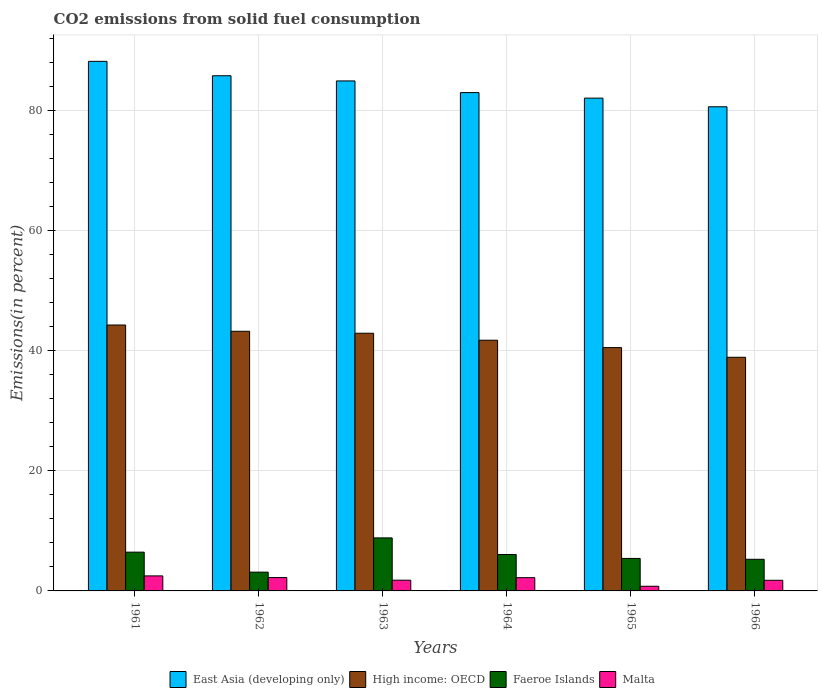How many different coloured bars are there?
Provide a short and direct response. 4. Are the number of bars on each tick of the X-axis equal?
Give a very brief answer. Yes. What is the label of the 5th group of bars from the left?
Your answer should be very brief. 1965. In how many cases, is the number of bars for a given year not equal to the number of legend labels?
Make the answer very short. 0. What is the total CO2 emitted in East Asia (developing only) in 1961?
Offer a terse response. 88.12. Across all years, what is the maximum total CO2 emitted in Malta?
Your answer should be compact. 2.5. Across all years, what is the minimum total CO2 emitted in High income: OECD?
Your answer should be very brief. 38.88. In which year was the total CO2 emitted in Malta minimum?
Your response must be concise. 1965. What is the total total CO2 emitted in East Asia (developing only) in the graph?
Your answer should be very brief. 504.17. What is the difference between the total CO2 emitted in Faeroe Islands in 1961 and that in 1966?
Make the answer very short. 1.19. What is the difference between the total CO2 emitted in Malta in 1966 and the total CO2 emitted in East Asia (developing only) in 1963?
Make the answer very short. -83.09. What is the average total CO2 emitted in High income: OECD per year?
Your answer should be very brief. 41.9. In the year 1964, what is the difference between the total CO2 emitted in Malta and total CO2 emitted in Faeroe Islands?
Make the answer very short. -3.85. What is the ratio of the total CO2 emitted in Malta in 1964 to that in 1966?
Give a very brief answer. 1.25. Is the difference between the total CO2 emitted in Malta in 1961 and 1966 greater than the difference between the total CO2 emitted in Faeroe Islands in 1961 and 1966?
Offer a terse response. No. What is the difference between the highest and the second highest total CO2 emitted in Faeroe Islands?
Your response must be concise. 2.37. What is the difference between the highest and the lowest total CO2 emitted in East Asia (developing only)?
Provide a succinct answer. 7.56. What does the 2nd bar from the left in 1963 represents?
Your answer should be very brief. High income: OECD. What does the 2nd bar from the right in 1966 represents?
Offer a terse response. Faeroe Islands. How many bars are there?
Keep it short and to the point. 24. Does the graph contain any zero values?
Provide a short and direct response. No. Does the graph contain grids?
Offer a terse response. Yes. Where does the legend appear in the graph?
Offer a very short reply. Bottom center. What is the title of the graph?
Provide a succinct answer. CO2 emissions from solid fuel consumption. Does "Burundi" appear as one of the legend labels in the graph?
Make the answer very short. No. What is the label or title of the X-axis?
Offer a terse response. Years. What is the label or title of the Y-axis?
Provide a succinct answer. Emissions(in percent). What is the Emissions(in percent) of East Asia (developing only) in 1961?
Keep it short and to the point. 88.12. What is the Emissions(in percent) in High income: OECD in 1961?
Give a very brief answer. 44.25. What is the Emissions(in percent) in Faeroe Islands in 1961?
Keep it short and to the point. 6.45. What is the Emissions(in percent) of East Asia (developing only) in 1962?
Provide a succinct answer. 85.72. What is the Emissions(in percent) in High income: OECD in 1962?
Your answer should be very brief. 43.2. What is the Emissions(in percent) of Faeroe Islands in 1962?
Ensure brevity in your answer.  3.12. What is the Emissions(in percent) in Malta in 1962?
Offer a very short reply. 2.22. What is the Emissions(in percent) of East Asia (developing only) in 1963?
Your answer should be compact. 84.86. What is the Emissions(in percent) of High income: OECD in 1963?
Your response must be concise. 42.88. What is the Emissions(in percent) of Faeroe Islands in 1963?
Keep it short and to the point. 8.82. What is the Emissions(in percent) of Malta in 1963?
Provide a succinct answer. 1.79. What is the Emissions(in percent) in East Asia (developing only) in 1964?
Provide a succinct answer. 82.92. What is the Emissions(in percent) in High income: OECD in 1964?
Your answer should be very brief. 41.72. What is the Emissions(in percent) in Faeroe Islands in 1964?
Provide a succinct answer. 6.06. What is the Emissions(in percent) of Malta in 1964?
Offer a terse response. 2.21. What is the Emissions(in percent) in East Asia (developing only) in 1965?
Offer a very short reply. 82. What is the Emissions(in percent) in High income: OECD in 1965?
Make the answer very short. 40.49. What is the Emissions(in percent) in Faeroe Islands in 1965?
Your answer should be compact. 5.41. What is the Emissions(in percent) of Malta in 1965?
Give a very brief answer. 0.78. What is the Emissions(in percent) of East Asia (developing only) in 1966?
Your answer should be very brief. 80.56. What is the Emissions(in percent) in High income: OECD in 1966?
Ensure brevity in your answer.  38.88. What is the Emissions(in percent) in Faeroe Islands in 1966?
Your answer should be very brief. 5.26. What is the Emissions(in percent) of Malta in 1966?
Your response must be concise. 1.77. Across all years, what is the maximum Emissions(in percent) of East Asia (developing only)?
Offer a terse response. 88.12. Across all years, what is the maximum Emissions(in percent) of High income: OECD?
Make the answer very short. 44.25. Across all years, what is the maximum Emissions(in percent) of Faeroe Islands?
Provide a succinct answer. 8.82. Across all years, what is the minimum Emissions(in percent) of East Asia (developing only)?
Your response must be concise. 80.56. Across all years, what is the minimum Emissions(in percent) of High income: OECD?
Provide a short and direct response. 38.88. Across all years, what is the minimum Emissions(in percent) in Faeroe Islands?
Give a very brief answer. 3.12. Across all years, what is the minimum Emissions(in percent) in Malta?
Keep it short and to the point. 0.78. What is the total Emissions(in percent) of East Asia (developing only) in the graph?
Offer a very short reply. 504.17. What is the total Emissions(in percent) in High income: OECD in the graph?
Give a very brief answer. 251.41. What is the total Emissions(in percent) of Faeroe Islands in the graph?
Provide a short and direct response. 35.13. What is the total Emissions(in percent) of Malta in the graph?
Keep it short and to the point. 11.26. What is the difference between the Emissions(in percent) in East Asia (developing only) in 1961 and that in 1962?
Offer a terse response. 2.4. What is the difference between the Emissions(in percent) of High income: OECD in 1961 and that in 1962?
Ensure brevity in your answer.  1.04. What is the difference between the Emissions(in percent) in Faeroe Islands in 1961 and that in 1962?
Keep it short and to the point. 3.33. What is the difference between the Emissions(in percent) of Malta in 1961 and that in 1962?
Your answer should be compact. 0.28. What is the difference between the Emissions(in percent) in East Asia (developing only) in 1961 and that in 1963?
Provide a succinct answer. 3.26. What is the difference between the Emissions(in percent) in High income: OECD in 1961 and that in 1963?
Offer a very short reply. 1.37. What is the difference between the Emissions(in percent) of Faeroe Islands in 1961 and that in 1963?
Ensure brevity in your answer.  -2.37. What is the difference between the Emissions(in percent) in East Asia (developing only) in 1961 and that in 1964?
Make the answer very short. 5.2. What is the difference between the Emissions(in percent) in High income: OECD in 1961 and that in 1964?
Offer a terse response. 2.53. What is the difference between the Emissions(in percent) of Faeroe Islands in 1961 and that in 1964?
Provide a succinct answer. 0.39. What is the difference between the Emissions(in percent) of Malta in 1961 and that in 1964?
Your response must be concise. 0.29. What is the difference between the Emissions(in percent) of East Asia (developing only) in 1961 and that in 1965?
Keep it short and to the point. 6.12. What is the difference between the Emissions(in percent) in High income: OECD in 1961 and that in 1965?
Keep it short and to the point. 3.76. What is the difference between the Emissions(in percent) in Faeroe Islands in 1961 and that in 1965?
Your answer should be very brief. 1.05. What is the difference between the Emissions(in percent) in Malta in 1961 and that in 1965?
Provide a succinct answer. 1.72. What is the difference between the Emissions(in percent) in East Asia (developing only) in 1961 and that in 1966?
Your answer should be compact. 7.56. What is the difference between the Emissions(in percent) of High income: OECD in 1961 and that in 1966?
Give a very brief answer. 5.37. What is the difference between the Emissions(in percent) of Faeroe Islands in 1961 and that in 1966?
Your answer should be very brief. 1.19. What is the difference between the Emissions(in percent) in Malta in 1961 and that in 1966?
Provide a succinct answer. 0.73. What is the difference between the Emissions(in percent) in East Asia (developing only) in 1962 and that in 1963?
Your answer should be very brief. 0.86. What is the difference between the Emissions(in percent) in High income: OECD in 1962 and that in 1963?
Provide a short and direct response. 0.33. What is the difference between the Emissions(in percent) in Faeroe Islands in 1962 and that in 1963?
Offer a very short reply. -5.7. What is the difference between the Emissions(in percent) of Malta in 1962 and that in 1963?
Ensure brevity in your answer.  0.44. What is the difference between the Emissions(in percent) in East Asia (developing only) in 1962 and that in 1964?
Your answer should be very brief. 2.8. What is the difference between the Emissions(in percent) in High income: OECD in 1962 and that in 1964?
Offer a very short reply. 1.49. What is the difference between the Emissions(in percent) in Faeroe Islands in 1962 and that in 1964?
Your response must be concise. -2.94. What is the difference between the Emissions(in percent) in Malta in 1962 and that in 1964?
Your answer should be compact. 0.02. What is the difference between the Emissions(in percent) of East Asia (developing only) in 1962 and that in 1965?
Keep it short and to the point. 3.72. What is the difference between the Emissions(in percent) of High income: OECD in 1962 and that in 1965?
Provide a short and direct response. 2.72. What is the difference between the Emissions(in percent) of Faeroe Islands in 1962 and that in 1965?
Offer a very short reply. -2.28. What is the difference between the Emissions(in percent) in Malta in 1962 and that in 1965?
Keep it short and to the point. 1.45. What is the difference between the Emissions(in percent) in East Asia (developing only) in 1962 and that in 1966?
Give a very brief answer. 5.16. What is the difference between the Emissions(in percent) of High income: OECD in 1962 and that in 1966?
Keep it short and to the point. 4.33. What is the difference between the Emissions(in percent) in Faeroe Islands in 1962 and that in 1966?
Your answer should be very brief. -2.14. What is the difference between the Emissions(in percent) of Malta in 1962 and that in 1966?
Offer a very short reply. 0.45. What is the difference between the Emissions(in percent) of East Asia (developing only) in 1963 and that in 1964?
Your response must be concise. 1.94. What is the difference between the Emissions(in percent) in High income: OECD in 1963 and that in 1964?
Your answer should be compact. 1.16. What is the difference between the Emissions(in percent) of Faeroe Islands in 1963 and that in 1964?
Your response must be concise. 2.76. What is the difference between the Emissions(in percent) of Malta in 1963 and that in 1964?
Make the answer very short. -0.42. What is the difference between the Emissions(in percent) in East Asia (developing only) in 1963 and that in 1965?
Your answer should be very brief. 2.86. What is the difference between the Emissions(in percent) of High income: OECD in 1963 and that in 1965?
Offer a very short reply. 2.39. What is the difference between the Emissions(in percent) of Faeroe Islands in 1963 and that in 1965?
Give a very brief answer. 3.42. What is the difference between the Emissions(in percent) in Malta in 1963 and that in 1965?
Your response must be concise. 1.01. What is the difference between the Emissions(in percent) in East Asia (developing only) in 1963 and that in 1966?
Provide a short and direct response. 4.3. What is the difference between the Emissions(in percent) of High income: OECD in 1963 and that in 1966?
Make the answer very short. 4. What is the difference between the Emissions(in percent) of Faeroe Islands in 1963 and that in 1966?
Provide a succinct answer. 3.56. What is the difference between the Emissions(in percent) of Malta in 1963 and that in 1966?
Offer a very short reply. 0.02. What is the difference between the Emissions(in percent) of East Asia (developing only) in 1964 and that in 1965?
Keep it short and to the point. 0.92. What is the difference between the Emissions(in percent) of High income: OECD in 1964 and that in 1965?
Ensure brevity in your answer.  1.23. What is the difference between the Emissions(in percent) in Faeroe Islands in 1964 and that in 1965?
Your answer should be very brief. 0.66. What is the difference between the Emissions(in percent) in Malta in 1964 and that in 1965?
Your answer should be compact. 1.43. What is the difference between the Emissions(in percent) in East Asia (developing only) in 1964 and that in 1966?
Make the answer very short. 2.36. What is the difference between the Emissions(in percent) in High income: OECD in 1964 and that in 1966?
Ensure brevity in your answer.  2.84. What is the difference between the Emissions(in percent) in Faeroe Islands in 1964 and that in 1966?
Offer a terse response. 0.8. What is the difference between the Emissions(in percent) in Malta in 1964 and that in 1966?
Keep it short and to the point. 0.44. What is the difference between the Emissions(in percent) of East Asia (developing only) in 1965 and that in 1966?
Provide a succinct answer. 1.44. What is the difference between the Emissions(in percent) of High income: OECD in 1965 and that in 1966?
Your answer should be compact. 1.61. What is the difference between the Emissions(in percent) of Faeroe Islands in 1965 and that in 1966?
Make the answer very short. 0.14. What is the difference between the Emissions(in percent) in Malta in 1965 and that in 1966?
Provide a short and direct response. -0.99. What is the difference between the Emissions(in percent) in East Asia (developing only) in 1961 and the Emissions(in percent) in High income: OECD in 1962?
Make the answer very short. 44.91. What is the difference between the Emissions(in percent) of East Asia (developing only) in 1961 and the Emissions(in percent) of Faeroe Islands in 1962?
Your response must be concise. 84.99. What is the difference between the Emissions(in percent) of East Asia (developing only) in 1961 and the Emissions(in percent) of Malta in 1962?
Offer a terse response. 85.9. What is the difference between the Emissions(in percent) in High income: OECD in 1961 and the Emissions(in percent) in Faeroe Islands in 1962?
Your answer should be very brief. 41.12. What is the difference between the Emissions(in percent) of High income: OECD in 1961 and the Emissions(in percent) of Malta in 1962?
Ensure brevity in your answer.  42.03. What is the difference between the Emissions(in percent) of Faeroe Islands in 1961 and the Emissions(in percent) of Malta in 1962?
Your answer should be very brief. 4.23. What is the difference between the Emissions(in percent) in East Asia (developing only) in 1961 and the Emissions(in percent) in High income: OECD in 1963?
Provide a short and direct response. 45.24. What is the difference between the Emissions(in percent) in East Asia (developing only) in 1961 and the Emissions(in percent) in Faeroe Islands in 1963?
Provide a succinct answer. 79.29. What is the difference between the Emissions(in percent) in East Asia (developing only) in 1961 and the Emissions(in percent) in Malta in 1963?
Your answer should be very brief. 86.33. What is the difference between the Emissions(in percent) of High income: OECD in 1961 and the Emissions(in percent) of Faeroe Islands in 1963?
Provide a succinct answer. 35.42. What is the difference between the Emissions(in percent) of High income: OECD in 1961 and the Emissions(in percent) of Malta in 1963?
Your answer should be compact. 42.46. What is the difference between the Emissions(in percent) of Faeroe Islands in 1961 and the Emissions(in percent) of Malta in 1963?
Make the answer very short. 4.67. What is the difference between the Emissions(in percent) of East Asia (developing only) in 1961 and the Emissions(in percent) of High income: OECD in 1964?
Offer a terse response. 46.4. What is the difference between the Emissions(in percent) of East Asia (developing only) in 1961 and the Emissions(in percent) of Faeroe Islands in 1964?
Keep it short and to the point. 82.06. What is the difference between the Emissions(in percent) of East Asia (developing only) in 1961 and the Emissions(in percent) of Malta in 1964?
Your answer should be compact. 85.91. What is the difference between the Emissions(in percent) of High income: OECD in 1961 and the Emissions(in percent) of Faeroe Islands in 1964?
Provide a short and direct response. 38.19. What is the difference between the Emissions(in percent) in High income: OECD in 1961 and the Emissions(in percent) in Malta in 1964?
Offer a very short reply. 42.04. What is the difference between the Emissions(in percent) of Faeroe Islands in 1961 and the Emissions(in percent) of Malta in 1964?
Make the answer very short. 4.25. What is the difference between the Emissions(in percent) in East Asia (developing only) in 1961 and the Emissions(in percent) in High income: OECD in 1965?
Provide a succinct answer. 47.63. What is the difference between the Emissions(in percent) in East Asia (developing only) in 1961 and the Emissions(in percent) in Faeroe Islands in 1965?
Provide a short and direct response. 82.71. What is the difference between the Emissions(in percent) of East Asia (developing only) in 1961 and the Emissions(in percent) of Malta in 1965?
Your answer should be compact. 87.34. What is the difference between the Emissions(in percent) in High income: OECD in 1961 and the Emissions(in percent) in Faeroe Islands in 1965?
Offer a terse response. 38.84. What is the difference between the Emissions(in percent) in High income: OECD in 1961 and the Emissions(in percent) in Malta in 1965?
Your answer should be very brief. 43.47. What is the difference between the Emissions(in percent) in Faeroe Islands in 1961 and the Emissions(in percent) in Malta in 1965?
Make the answer very short. 5.68. What is the difference between the Emissions(in percent) in East Asia (developing only) in 1961 and the Emissions(in percent) in High income: OECD in 1966?
Offer a very short reply. 49.24. What is the difference between the Emissions(in percent) in East Asia (developing only) in 1961 and the Emissions(in percent) in Faeroe Islands in 1966?
Offer a terse response. 82.85. What is the difference between the Emissions(in percent) in East Asia (developing only) in 1961 and the Emissions(in percent) in Malta in 1966?
Ensure brevity in your answer.  86.35. What is the difference between the Emissions(in percent) in High income: OECD in 1961 and the Emissions(in percent) in Faeroe Islands in 1966?
Ensure brevity in your answer.  38.98. What is the difference between the Emissions(in percent) in High income: OECD in 1961 and the Emissions(in percent) in Malta in 1966?
Your response must be concise. 42.48. What is the difference between the Emissions(in percent) of Faeroe Islands in 1961 and the Emissions(in percent) of Malta in 1966?
Offer a very short reply. 4.68. What is the difference between the Emissions(in percent) of East Asia (developing only) in 1962 and the Emissions(in percent) of High income: OECD in 1963?
Your response must be concise. 42.84. What is the difference between the Emissions(in percent) of East Asia (developing only) in 1962 and the Emissions(in percent) of Faeroe Islands in 1963?
Give a very brief answer. 76.9. What is the difference between the Emissions(in percent) in East Asia (developing only) in 1962 and the Emissions(in percent) in Malta in 1963?
Your answer should be compact. 83.94. What is the difference between the Emissions(in percent) in High income: OECD in 1962 and the Emissions(in percent) in Faeroe Islands in 1963?
Ensure brevity in your answer.  34.38. What is the difference between the Emissions(in percent) of High income: OECD in 1962 and the Emissions(in percent) of Malta in 1963?
Your answer should be very brief. 41.42. What is the difference between the Emissions(in percent) in Faeroe Islands in 1962 and the Emissions(in percent) in Malta in 1963?
Your response must be concise. 1.34. What is the difference between the Emissions(in percent) in East Asia (developing only) in 1962 and the Emissions(in percent) in High income: OECD in 1964?
Offer a terse response. 44.01. What is the difference between the Emissions(in percent) of East Asia (developing only) in 1962 and the Emissions(in percent) of Faeroe Islands in 1964?
Your response must be concise. 79.66. What is the difference between the Emissions(in percent) in East Asia (developing only) in 1962 and the Emissions(in percent) in Malta in 1964?
Offer a terse response. 83.52. What is the difference between the Emissions(in percent) of High income: OECD in 1962 and the Emissions(in percent) of Faeroe Islands in 1964?
Keep it short and to the point. 37.14. What is the difference between the Emissions(in percent) in High income: OECD in 1962 and the Emissions(in percent) in Malta in 1964?
Make the answer very short. 41. What is the difference between the Emissions(in percent) of Faeroe Islands in 1962 and the Emissions(in percent) of Malta in 1964?
Provide a short and direct response. 0.92. What is the difference between the Emissions(in percent) in East Asia (developing only) in 1962 and the Emissions(in percent) in High income: OECD in 1965?
Give a very brief answer. 45.23. What is the difference between the Emissions(in percent) in East Asia (developing only) in 1962 and the Emissions(in percent) in Faeroe Islands in 1965?
Provide a short and direct response. 80.32. What is the difference between the Emissions(in percent) in East Asia (developing only) in 1962 and the Emissions(in percent) in Malta in 1965?
Give a very brief answer. 84.95. What is the difference between the Emissions(in percent) of High income: OECD in 1962 and the Emissions(in percent) of Faeroe Islands in 1965?
Provide a short and direct response. 37.8. What is the difference between the Emissions(in percent) of High income: OECD in 1962 and the Emissions(in percent) of Malta in 1965?
Offer a terse response. 42.43. What is the difference between the Emissions(in percent) of Faeroe Islands in 1962 and the Emissions(in percent) of Malta in 1965?
Keep it short and to the point. 2.35. What is the difference between the Emissions(in percent) of East Asia (developing only) in 1962 and the Emissions(in percent) of High income: OECD in 1966?
Give a very brief answer. 46.84. What is the difference between the Emissions(in percent) in East Asia (developing only) in 1962 and the Emissions(in percent) in Faeroe Islands in 1966?
Make the answer very short. 80.46. What is the difference between the Emissions(in percent) in East Asia (developing only) in 1962 and the Emissions(in percent) in Malta in 1966?
Make the answer very short. 83.95. What is the difference between the Emissions(in percent) in High income: OECD in 1962 and the Emissions(in percent) in Faeroe Islands in 1966?
Your answer should be very brief. 37.94. What is the difference between the Emissions(in percent) of High income: OECD in 1962 and the Emissions(in percent) of Malta in 1966?
Your answer should be very brief. 41.43. What is the difference between the Emissions(in percent) in Faeroe Islands in 1962 and the Emissions(in percent) in Malta in 1966?
Provide a succinct answer. 1.36. What is the difference between the Emissions(in percent) in East Asia (developing only) in 1963 and the Emissions(in percent) in High income: OECD in 1964?
Your response must be concise. 43.14. What is the difference between the Emissions(in percent) of East Asia (developing only) in 1963 and the Emissions(in percent) of Faeroe Islands in 1964?
Your response must be concise. 78.8. What is the difference between the Emissions(in percent) of East Asia (developing only) in 1963 and the Emissions(in percent) of Malta in 1964?
Keep it short and to the point. 82.65. What is the difference between the Emissions(in percent) in High income: OECD in 1963 and the Emissions(in percent) in Faeroe Islands in 1964?
Give a very brief answer. 36.82. What is the difference between the Emissions(in percent) in High income: OECD in 1963 and the Emissions(in percent) in Malta in 1964?
Offer a terse response. 40.67. What is the difference between the Emissions(in percent) in Faeroe Islands in 1963 and the Emissions(in percent) in Malta in 1964?
Offer a terse response. 6.62. What is the difference between the Emissions(in percent) in East Asia (developing only) in 1963 and the Emissions(in percent) in High income: OECD in 1965?
Offer a very short reply. 44.37. What is the difference between the Emissions(in percent) in East Asia (developing only) in 1963 and the Emissions(in percent) in Faeroe Islands in 1965?
Give a very brief answer. 79.45. What is the difference between the Emissions(in percent) in East Asia (developing only) in 1963 and the Emissions(in percent) in Malta in 1965?
Offer a very short reply. 84.08. What is the difference between the Emissions(in percent) in High income: OECD in 1963 and the Emissions(in percent) in Faeroe Islands in 1965?
Make the answer very short. 37.47. What is the difference between the Emissions(in percent) of High income: OECD in 1963 and the Emissions(in percent) of Malta in 1965?
Make the answer very short. 42.1. What is the difference between the Emissions(in percent) of Faeroe Islands in 1963 and the Emissions(in percent) of Malta in 1965?
Offer a very short reply. 8.05. What is the difference between the Emissions(in percent) in East Asia (developing only) in 1963 and the Emissions(in percent) in High income: OECD in 1966?
Your answer should be very brief. 45.98. What is the difference between the Emissions(in percent) of East Asia (developing only) in 1963 and the Emissions(in percent) of Faeroe Islands in 1966?
Provide a short and direct response. 79.6. What is the difference between the Emissions(in percent) of East Asia (developing only) in 1963 and the Emissions(in percent) of Malta in 1966?
Your response must be concise. 83.09. What is the difference between the Emissions(in percent) of High income: OECD in 1963 and the Emissions(in percent) of Faeroe Islands in 1966?
Provide a succinct answer. 37.61. What is the difference between the Emissions(in percent) of High income: OECD in 1963 and the Emissions(in percent) of Malta in 1966?
Make the answer very short. 41.11. What is the difference between the Emissions(in percent) in Faeroe Islands in 1963 and the Emissions(in percent) in Malta in 1966?
Your answer should be very brief. 7.05. What is the difference between the Emissions(in percent) of East Asia (developing only) in 1964 and the Emissions(in percent) of High income: OECD in 1965?
Keep it short and to the point. 42.43. What is the difference between the Emissions(in percent) of East Asia (developing only) in 1964 and the Emissions(in percent) of Faeroe Islands in 1965?
Offer a very short reply. 77.51. What is the difference between the Emissions(in percent) in East Asia (developing only) in 1964 and the Emissions(in percent) in Malta in 1965?
Your answer should be compact. 82.14. What is the difference between the Emissions(in percent) of High income: OECD in 1964 and the Emissions(in percent) of Faeroe Islands in 1965?
Keep it short and to the point. 36.31. What is the difference between the Emissions(in percent) of High income: OECD in 1964 and the Emissions(in percent) of Malta in 1965?
Your answer should be compact. 40.94. What is the difference between the Emissions(in percent) of Faeroe Islands in 1964 and the Emissions(in percent) of Malta in 1965?
Your answer should be very brief. 5.29. What is the difference between the Emissions(in percent) of East Asia (developing only) in 1964 and the Emissions(in percent) of High income: OECD in 1966?
Provide a short and direct response. 44.04. What is the difference between the Emissions(in percent) of East Asia (developing only) in 1964 and the Emissions(in percent) of Faeroe Islands in 1966?
Offer a very short reply. 77.65. What is the difference between the Emissions(in percent) of East Asia (developing only) in 1964 and the Emissions(in percent) of Malta in 1966?
Give a very brief answer. 81.15. What is the difference between the Emissions(in percent) of High income: OECD in 1964 and the Emissions(in percent) of Faeroe Islands in 1966?
Your answer should be very brief. 36.45. What is the difference between the Emissions(in percent) in High income: OECD in 1964 and the Emissions(in percent) in Malta in 1966?
Your answer should be compact. 39.95. What is the difference between the Emissions(in percent) of Faeroe Islands in 1964 and the Emissions(in percent) of Malta in 1966?
Provide a succinct answer. 4.29. What is the difference between the Emissions(in percent) in East Asia (developing only) in 1965 and the Emissions(in percent) in High income: OECD in 1966?
Offer a very short reply. 43.12. What is the difference between the Emissions(in percent) in East Asia (developing only) in 1965 and the Emissions(in percent) in Faeroe Islands in 1966?
Provide a short and direct response. 76.73. What is the difference between the Emissions(in percent) of East Asia (developing only) in 1965 and the Emissions(in percent) of Malta in 1966?
Ensure brevity in your answer.  80.23. What is the difference between the Emissions(in percent) of High income: OECD in 1965 and the Emissions(in percent) of Faeroe Islands in 1966?
Keep it short and to the point. 35.23. What is the difference between the Emissions(in percent) of High income: OECD in 1965 and the Emissions(in percent) of Malta in 1966?
Your answer should be compact. 38.72. What is the difference between the Emissions(in percent) of Faeroe Islands in 1965 and the Emissions(in percent) of Malta in 1966?
Ensure brevity in your answer.  3.64. What is the average Emissions(in percent) of East Asia (developing only) per year?
Give a very brief answer. 84.03. What is the average Emissions(in percent) in High income: OECD per year?
Give a very brief answer. 41.9. What is the average Emissions(in percent) in Faeroe Islands per year?
Keep it short and to the point. 5.85. What is the average Emissions(in percent) of Malta per year?
Give a very brief answer. 1.88. In the year 1961, what is the difference between the Emissions(in percent) of East Asia (developing only) and Emissions(in percent) of High income: OECD?
Your answer should be compact. 43.87. In the year 1961, what is the difference between the Emissions(in percent) in East Asia (developing only) and Emissions(in percent) in Faeroe Islands?
Provide a short and direct response. 81.67. In the year 1961, what is the difference between the Emissions(in percent) of East Asia (developing only) and Emissions(in percent) of Malta?
Give a very brief answer. 85.62. In the year 1961, what is the difference between the Emissions(in percent) in High income: OECD and Emissions(in percent) in Faeroe Islands?
Provide a short and direct response. 37.8. In the year 1961, what is the difference between the Emissions(in percent) in High income: OECD and Emissions(in percent) in Malta?
Ensure brevity in your answer.  41.75. In the year 1961, what is the difference between the Emissions(in percent) of Faeroe Islands and Emissions(in percent) of Malta?
Provide a succinct answer. 3.95. In the year 1962, what is the difference between the Emissions(in percent) of East Asia (developing only) and Emissions(in percent) of High income: OECD?
Your response must be concise. 42.52. In the year 1962, what is the difference between the Emissions(in percent) in East Asia (developing only) and Emissions(in percent) in Faeroe Islands?
Your response must be concise. 82.6. In the year 1962, what is the difference between the Emissions(in percent) of East Asia (developing only) and Emissions(in percent) of Malta?
Ensure brevity in your answer.  83.5. In the year 1962, what is the difference between the Emissions(in percent) in High income: OECD and Emissions(in percent) in Faeroe Islands?
Make the answer very short. 40.08. In the year 1962, what is the difference between the Emissions(in percent) of High income: OECD and Emissions(in percent) of Malta?
Your answer should be very brief. 40.98. In the year 1962, what is the difference between the Emissions(in percent) in Faeroe Islands and Emissions(in percent) in Malta?
Provide a succinct answer. 0.9. In the year 1963, what is the difference between the Emissions(in percent) of East Asia (developing only) and Emissions(in percent) of High income: OECD?
Keep it short and to the point. 41.98. In the year 1963, what is the difference between the Emissions(in percent) of East Asia (developing only) and Emissions(in percent) of Faeroe Islands?
Ensure brevity in your answer.  76.04. In the year 1963, what is the difference between the Emissions(in percent) in East Asia (developing only) and Emissions(in percent) in Malta?
Your response must be concise. 83.07. In the year 1963, what is the difference between the Emissions(in percent) in High income: OECD and Emissions(in percent) in Faeroe Islands?
Offer a terse response. 34.05. In the year 1963, what is the difference between the Emissions(in percent) of High income: OECD and Emissions(in percent) of Malta?
Give a very brief answer. 41.09. In the year 1963, what is the difference between the Emissions(in percent) in Faeroe Islands and Emissions(in percent) in Malta?
Ensure brevity in your answer.  7.04. In the year 1964, what is the difference between the Emissions(in percent) in East Asia (developing only) and Emissions(in percent) in High income: OECD?
Offer a terse response. 41.2. In the year 1964, what is the difference between the Emissions(in percent) of East Asia (developing only) and Emissions(in percent) of Faeroe Islands?
Offer a very short reply. 76.86. In the year 1964, what is the difference between the Emissions(in percent) of East Asia (developing only) and Emissions(in percent) of Malta?
Your answer should be very brief. 80.71. In the year 1964, what is the difference between the Emissions(in percent) in High income: OECD and Emissions(in percent) in Faeroe Islands?
Make the answer very short. 35.66. In the year 1964, what is the difference between the Emissions(in percent) in High income: OECD and Emissions(in percent) in Malta?
Provide a succinct answer. 39.51. In the year 1964, what is the difference between the Emissions(in percent) of Faeroe Islands and Emissions(in percent) of Malta?
Ensure brevity in your answer.  3.85. In the year 1965, what is the difference between the Emissions(in percent) of East Asia (developing only) and Emissions(in percent) of High income: OECD?
Your answer should be compact. 41.51. In the year 1965, what is the difference between the Emissions(in percent) in East Asia (developing only) and Emissions(in percent) in Faeroe Islands?
Your response must be concise. 76.59. In the year 1965, what is the difference between the Emissions(in percent) of East Asia (developing only) and Emissions(in percent) of Malta?
Your answer should be compact. 81.22. In the year 1965, what is the difference between the Emissions(in percent) in High income: OECD and Emissions(in percent) in Faeroe Islands?
Your answer should be compact. 35.08. In the year 1965, what is the difference between the Emissions(in percent) in High income: OECD and Emissions(in percent) in Malta?
Your response must be concise. 39.71. In the year 1965, what is the difference between the Emissions(in percent) of Faeroe Islands and Emissions(in percent) of Malta?
Give a very brief answer. 4.63. In the year 1966, what is the difference between the Emissions(in percent) of East Asia (developing only) and Emissions(in percent) of High income: OECD?
Your response must be concise. 41.68. In the year 1966, what is the difference between the Emissions(in percent) in East Asia (developing only) and Emissions(in percent) in Faeroe Islands?
Offer a very short reply. 75.29. In the year 1966, what is the difference between the Emissions(in percent) in East Asia (developing only) and Emissions(in percent) in Malta?
Your answer should be compact. 78.79. In the year 1966, what is the difference between the Emissions(in percent) of High income: OECD and Emissions(in percent) of Faeroe Islands?
Your response must be concise. 33.62. In the year 1966, what is the difference between the Emissions(in percent) of High income: OECD and Emissions(in percent) of Malta?
Give a very brief answer. 37.11. In the year 1966, what is the difference between the Emissions(in percent) of Faeroe Islands and Emissions(in percent) of Malta?
Your answer should be very brief. 3.49. What is the ratio of the Emissions(in percent) of East Asia (developing only) in 1961 to that in 1962?
Provide a succinct answer. 1.03. What is the ratio of the Emissions(in percent) in High income: OECD in 1961 to that in 1962?
Keep it short and to the point. 1.02. What is the ratio of the Emissions(in percent) in Faeroe Islands in 1961 to that in 1962?
Your response must be concise. 2.06. What is the ratio of the Emissions(in percent) of Malta in 1961 to that in 1962?
Your answer should be very brief. 1.12. What is the ratio of the Emissions(in percent) of East Asia (developing only) in 1961 to that in 1963?
Your answer should be compact. 1.04. What is the ratio of the Emissions(in percent) in High income: OECD in 1961 to that in 1963?
Provide a short and direct response. 1.03. What is the ratio of the Emissions(in percent) of Faeroe Islands in 1961 to that in 1963?
Your response must be concise. 0.73. What is the ratio of the Emissions(in percent) in East Asia (developing only) in 1961 to that in 1964?
Offer a terse response. 1.06. What is the ratio of the Emissions(in percent) in High income: OECD in 1961 to that in 1964?
Keep it short and to the point. 1.06. What is the ratio of the Emissions(in percent) in Faeroe Islands in 1961 to that in 1964?
Your answer should be compact. 1.06. What is the ratio of the Emissions(in percent) in Malta in 1961 to that in 1964?
Offer a terse response. 1.13. What is the ratio of the Emissions(in percent) in East Asia (developing only) in 1961 to that in 1965?
Your answer should be very brief. 1.07. What is the ratio of the Emissions(in percent) of High income: OECD in 1961 to that in 1965?
Keep it short and to the point. 1.09. What is the ratio of the Emissions(in percent) of Faeroe Islands in 1961 to that in 1965?
Your answer should be compact. 1.19. What is the ratio of the Emissions(in percent) of Malta in 1961 to that in 1965?
Offer a very short reply. 3.23. What is the ratio of the Emissions(in percent) in East Asia (developing only) in 1961 to that in 1966?
Ensure brevity in your answer.  1.09. What is the ratio of the Emissions(in percent) of High income: OECD in 1961 to that in 1966?
Your answer should be compact. 1.14. What is the ratio of the Emissions(in percent) of Faeroe Islands in 1961 to that in 1966?
Ensure brevity in your answer.  1.23. What is the ratio of the Emissions(in percent) in Malta in 1961 to that in 1966?
Offer a very short reply. 1.41. What is the ratio of the Emissions(in percent) of East Asia (developing only) in 1962 to that in 1963?
Keep it short and to the point. 1.01. What is the ratio of the Emissions(in percent) of High income: OECD in 1962 to that in 1963?
Offer a very short reply. 1.01. What is the ratio of the Emissions(in percent) of Faeroe Islands in 1962 to that in 1963?
Ensure brevity in your answer.  0.35. What is the ratio of the Emissions(in percent) of Malta in 1962 to that in 1963?
Ensure brevity in your answer.  1.24. What is the ratio of the Emissions(in percent) in East Asia (developing only) in 1962 to that in 1964?
Provide a succinct answer. 1.03. What is the ratio of the Emissions(in percent) of High income: OECD in 1962 to that in 1964?
Provide a succinct answer. 1.04. What is the ratio of the Emissions(in percent) in Faeroe Islands in 1962 to that in 1964?
Keep it short and to the point. 0.52. What is the ratio of the Emissions(in percent) in Malta in 1962 to that in 1964?
Your response must be concise. 1.01. What is the ratio of the Emissions(in percent) of East Asia (developing only) in 1962 to that in 1965?
Provide a short and direct response. 1.05. What is the ratio of the Emissions(in percent) in High income: OECD in 1962 to that in 1965?
Ensure brevity in your answer.  1.07. What is the ratio of the Emissions(in percent) in Faeroe Islands in 1962 to that in 1965?
Your answer should be compact. 0.58. What is the ratio of the Emissions(in percent) of Malta in 1962 to that in 1965?
Your response must be concise. 2.87. What is the ratio of the Emissions(in percent) in East Asia (developing only) in 1962 to that in 1966?
Offer a very short reply. 1.06. What is the ratio of the Emissions(in percent) of High income: OECD in 1962 to that in 1966?
Your answer should be compact. 1.11. What is the ratio of the Emissions(in percent) in Faeroe Islands in 1962 to that in 1966?
Provide a short and direct response. 0.59. What is the ratio of the Emissions(in percent) of Malta in 1962 to that in 1966?
Keep it short and to the point. 1.26. What is the ratio of the Emissions(in percent) of East Asia (developing only) in 1963 to that in 1964?
Offer a terse response. 1.02. What is the ratio of the Emissions(in percent) of High income: OECD in 1963 to that in 1964?
Make the answer very short. 1.03. What is the ratio of the Emissions(in percent) in Faeroe Islands in 1963 to that in 1964?
Your answer should be compact. 1.46. What is the ratio of the Emissions(in percent) of Malta in 1963 to that in 1964?
Your response must be concise. 0.81. What is the ratio of the Emissions(in percent) of East Asia (developing only) in 1963 to that in 1965?
Provide a succinct answer. 1.03. What is the ratio of the Emissions(in percent) of High income: OECD in 1963 to that in 1965?
Provide a succinct answer. 1.06. What is the ratio of the Emissions(in percent) of Faeroe Islands in 1963 to that in 1965?
Your answer should be compact. 1.63. What is the ratio of the Emissions(in percent) in Malta in 1963 to that in 1965?
Ensure brevity in your answer.  2.3. What is the ratio of the Emissions(in percent) of East Asia (developing only) in 1963 to that in 1966?
Your answer should be very brief. 1.05. What is the ratio of the Emissions(in percent) of High income: OECD in 1963 to that in 1966?
Give a very brief answer. 1.1. What is the ratio of the Emissions(in percent) of Faeroe Islands in 1963 to that in 1966?
Make the answer very short. 1.68. What is the ratio of the Emissions(in percent) of Malta in 1963 to that in 1966?
Your answer should be very brief. 1.01. What is the ratio of the Emissions(in percent) of East Asia (developing only) in 1964 to that in 1965?
Offer a very short reply. 1.01. What is the ratio of the Emissions(in percent) of High income: OECD in 1964 to that in 1965?
Your answer should be compact. 1.03. What is the ratio of the Emissions(in percent) in Faeroe Islands in 1964 to that in 1965?
Ensure brevity in your answer.  1.12. What is the ratio of the Emissions(in percent) in Malta in 1964 to that in 1965?
Provide a short and direct response. 2.85. What is the ratio of the Emissions(in percent) in East Asia (developing only) in 1964 to that in 1966?
Ensure brevity in your answer.  1.03. What is the ratio of the Emissions(in percent) of High income: OECD in 1964 to that in 1966?
Ensure brevity in your answer.  1.07. What is the ratio of the Emissions(in percent) in Faeroe Islands in 1964 to that in 1966?
Your answer should be compact. 1.15. What is the ratio of the Emissions(in percent) of Malta in 1964 to that in 1966?
Provide a succinct answer. 1.25. What is the ratio of the Emissions(in percent) in East Asia (developing only) in 1965 to that in 1966?
Provide a succinct answer. 1.02. What is the ratio of the Emissions(in percent) of High income: OECD in 1965 to that in 1966?
Ensure brevity in your answer.  1.04. What is the ratio of the Emissions(in percent) in Malta in 1965 to that in 1966?
Your response must be concise. 0.44. What is the difference between the highest and the second highest Emissions(in percent) in East Asia (developing only)?
Give a very brief answer. 2.4. What is the difference between the highest and the second highest Emissions(in percent) of High income: OECD?
Your response must be concise. 1.04. What is the difference between the highest and the second highest Emissions(in percent) in Faeroe Islands?
Ensure brevity in your answer.  2.37. What is the difference between the highest and the second highest Emissions(in percent) in Malta?
Your answer should be very brief. 0.28. What is the difference between the highest and the lowest Emissions(in percent) of East Asia (developing only)?
Your answer should be very brief. 7.56. What is the difference between the highest and the lowest Emissions(in percent) of High income: OECD?
Your response must be concise. 5.37. What is the difference between the highest and the lowest Emissions(in percent) of Faeroe Islands?
Your response must be concise. 5.7. What is the difference between the highest and the lowest Emissions(in percent) of Malta?
Provide a succinct answer. 1.72. 